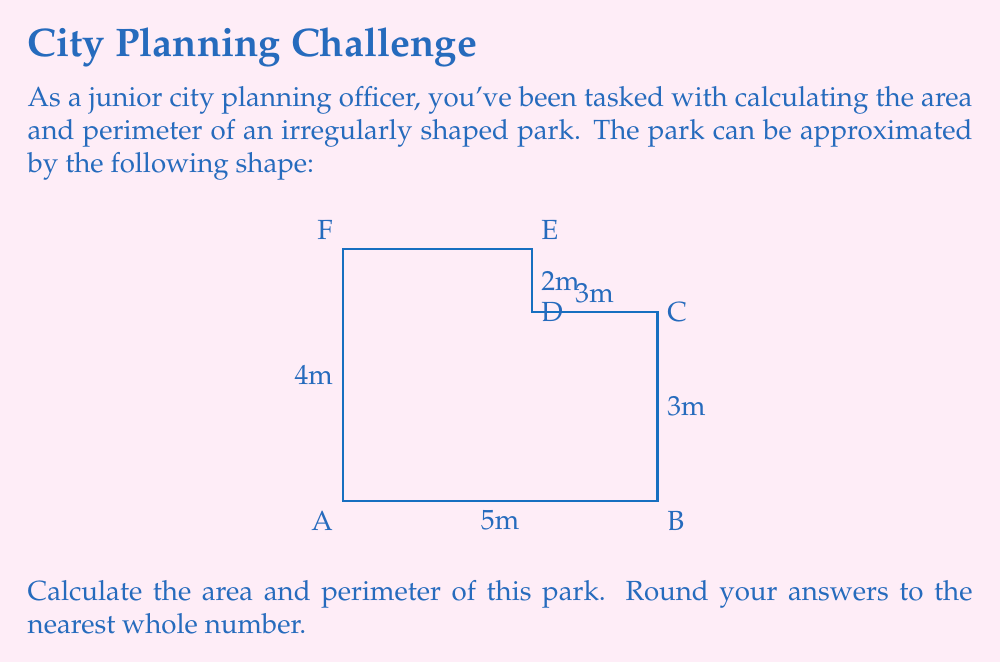Could you help me with this problem? To solve this problem, we'll break it down into steps:

1) Area Calculation:
   The park can be divided into two rectangles:
   - Rectangle 1: 5m x 3m
   - Rectangle 2: 3m x 1m

   Area of Rectangle 1: $A_1 = 5m \times 3m = 15m^2$
   Area of Rectangle 2: $A_2 = 3m \times 1m = 3m^2$

   Total Area: $A_{total} = A_1 + A_2 = 15m^2 + 3m^2 = 18m^2$

2) Perimeter Calculation:
   We need to sum up all the sides:
   $$P = 5m + 3m + 2m + 3m + 1m + 4m = 18m$$

3) Rounding:
   Area: 18m² (already a whole number)
   Perimeter: 18m (already a whole number)

Therefore, the area is 18 square meters and the perimeter is 18 meters.
Answer: Area: 18m², Perimeter: 18m 